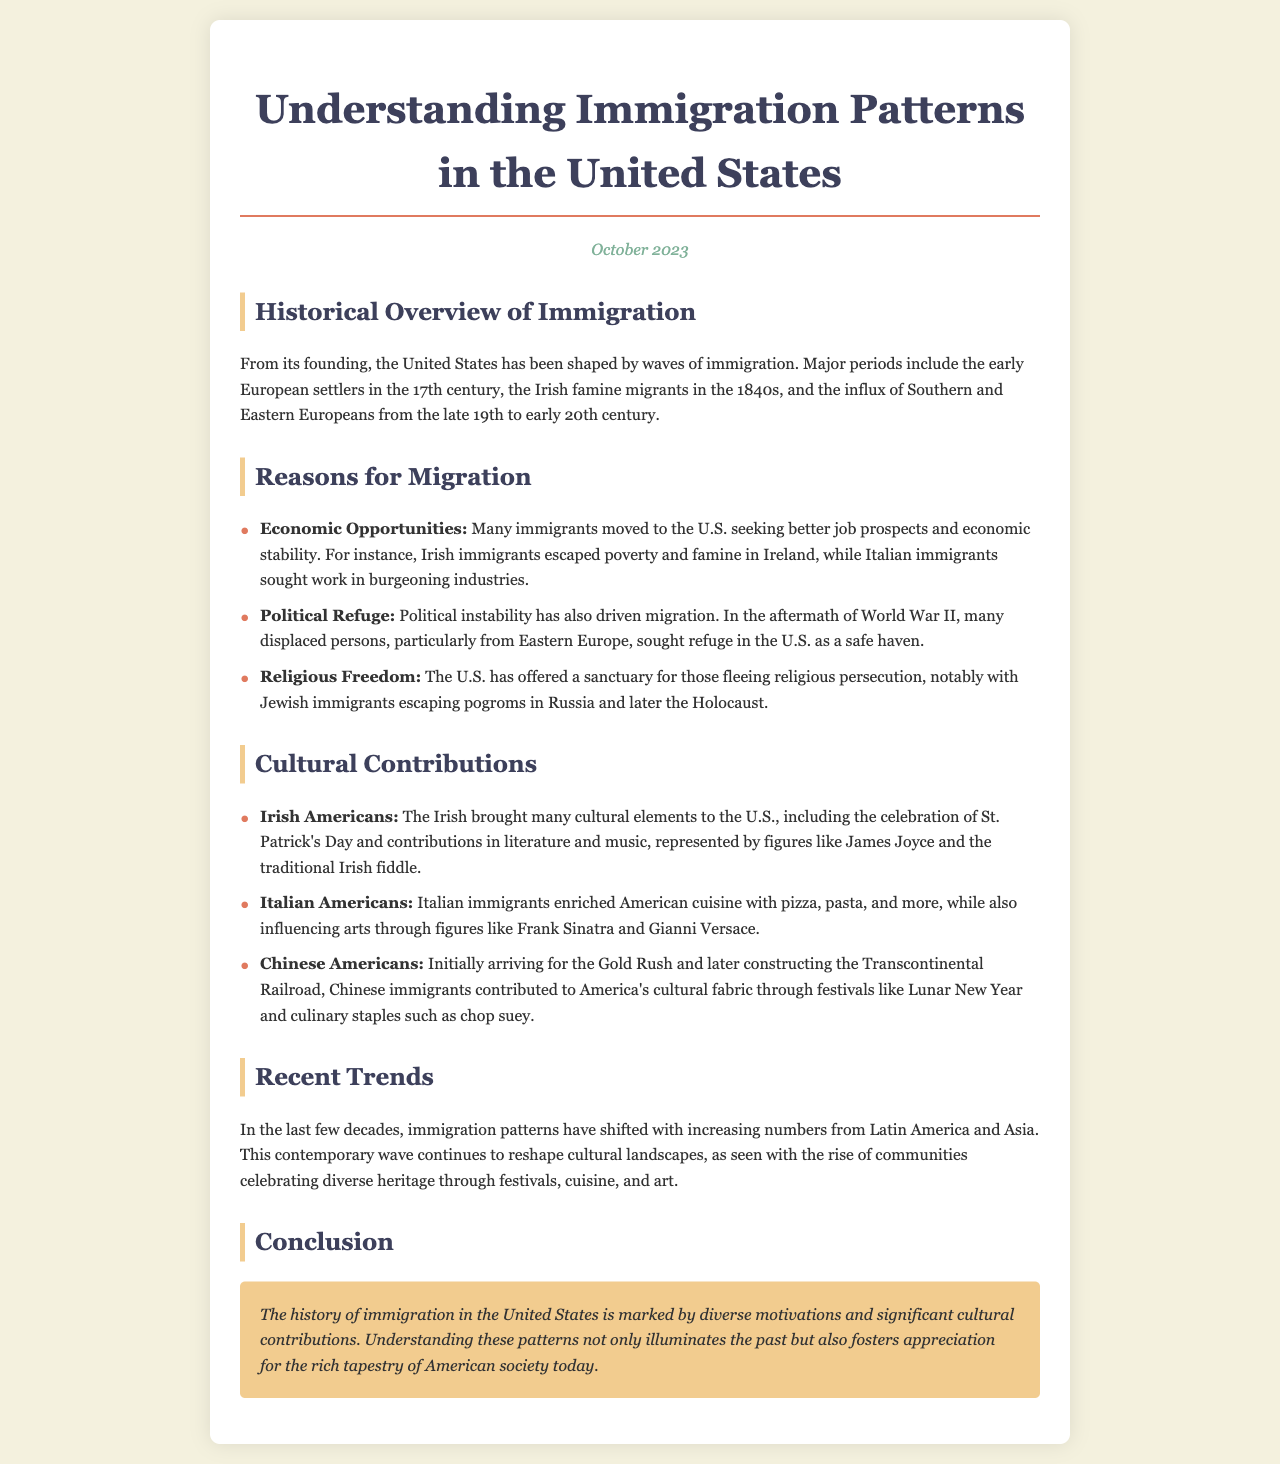What was a major reason for Irish migration? The document states that many Irish immigrants escaped poverty and famine in Ireland, indicating economic hardship as a primary reason for migration.
Answer: Economic Opportunities Which significant event prompted political refugees from Eastern Europe? According to the document, many displaced persons sought refuge in the U.S. in the aftermath of World War II, highlighting the impact of this conflict on migration.
Answer: World War II What cultural celebration is associated with Irish Americans? The newsletter mentions that Irish Americans brought the celebration of St. Patrick's Day to the U.S., showcasing their cultural contributions.
Answer: St. Patrick's Day Which cuisine was enriched by Italian immigrants? The document specifically notes that Italian immigrants introduced pizza and pasta to American cuisine, highlighting their culinary impact.
Answer: Pizza and pasta What recent trend in immigration does the document mention? The content indicates that the last few decades have seen an increase in immigration from Latin America and Asia, suggesting a shift in patterns.
Answer: Latin America and Asia What is the title of the newsletter? The title is provided at the top of the document, encapsulating the main theme of the content regarding immigration.
Answer: Understanding Immigration Patterns in the United States What is the document's publication date? The date presented in the newsletter indicates when this edition was released, providing a reference point for its content.
Answer: October 2023 Who is a notable figure mentioned in relation to Italian American contributions? The newsletter highlights figures like Frank Sinatra as examples of Italian Americans who influenced arts and culture in the U.S.
Answer: Frank Sinatra 